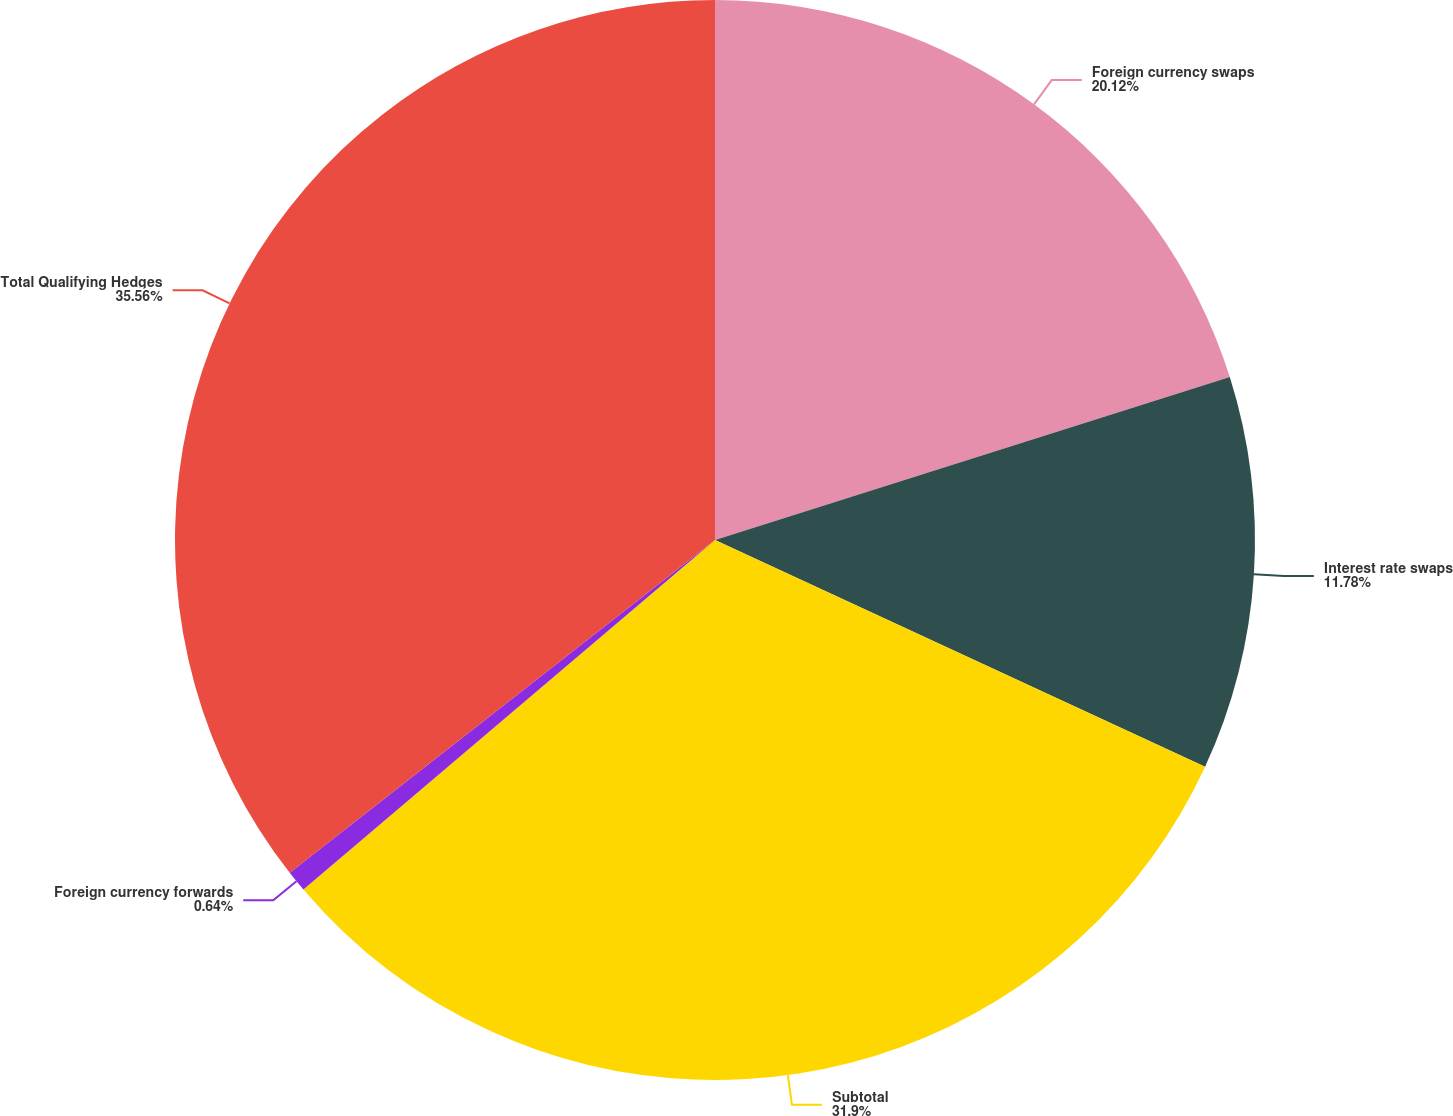Convert chart to OTSL. <chart><loc_0><loc_0><loc_500><loc_500><pie_chart><fcel>Foreign currency swaps<fcel>Interest rate swaps<fcel>Subtotal<fcel>Foreign currency forwards<fcel>Total Qualifying Hedges<nl><fcel>20.12%<fcel>11.78%<fcel>31.9%<fcel>0.64%<fcel>35.57%<nl></chart> 